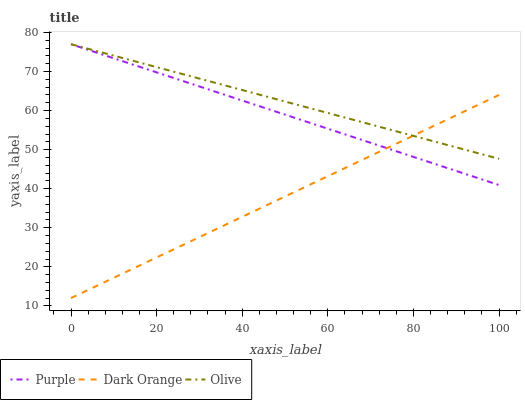Does Olive have the minimum area under the curve?
Answer yes or no. No. Does Dark Orange have the maximum area under the curve?
Answer yes or no. No. Is Olive the smoothest?
Answer yes or no. No. Is Olive the roughest?
Answer yes or no. No. Does Olive have the lowest value?
Answer yes or no. No. Does Dark Orange have the highest value?
Answer yes or no. No. 